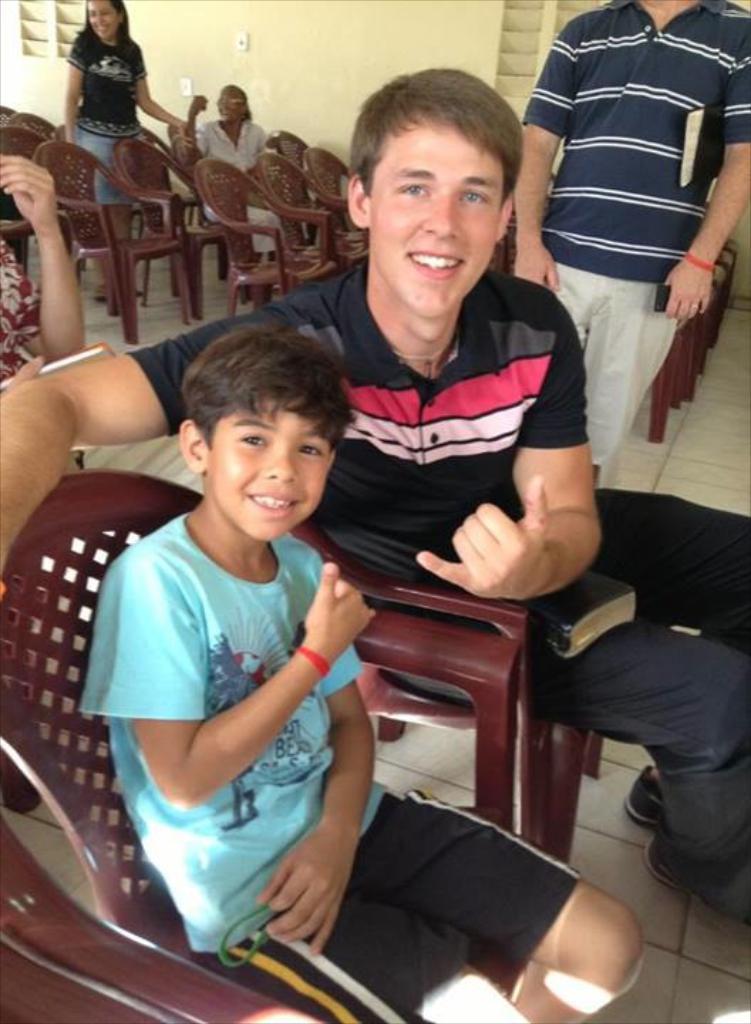In one or two sentences, can you explain what this image depicts? Here two boys are sitting in the chairs and smiling behind them there are chairs and a girl is standing at there and a wall at here. 